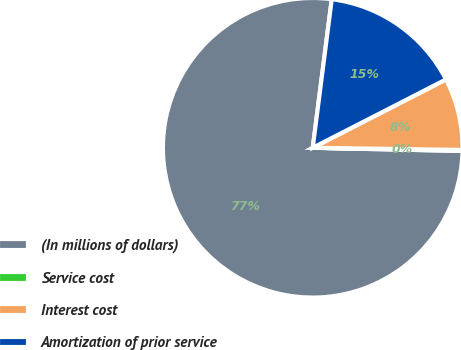Convert chart. <chart><loc_0><loc_0><loc_500><loc_500><pie_chart><fcel>(In millions of dollars)<fcel>Service cost<fcel>Interest cost<fcel>Amortization of prior service<nl><fcel>76.69%<fcel>0.11%<fcel>7.77%<fcel>15.43%<nl></chart> 